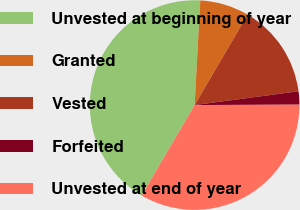Convert chart. <chart><loc_0><loc_0><loc_500><loc_500><pie_chart><fcel>Unvested at beginning of year<fcel>Granted<fcel>Vested<fcel>Forfeited<fcel>Unvested at end of year<nl><fcel>42.42%<fcel>7.58%<fcel>14.46%<fcel>2.04%<fcel>33.49%<nl></chart> 